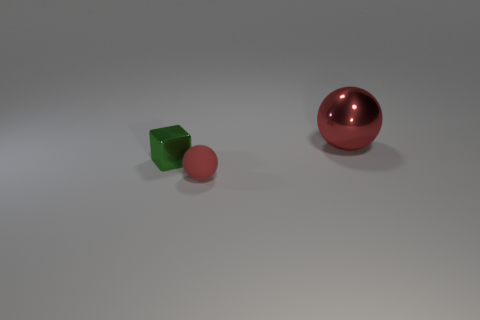What number of other objects are the same shape as the green object? 0 